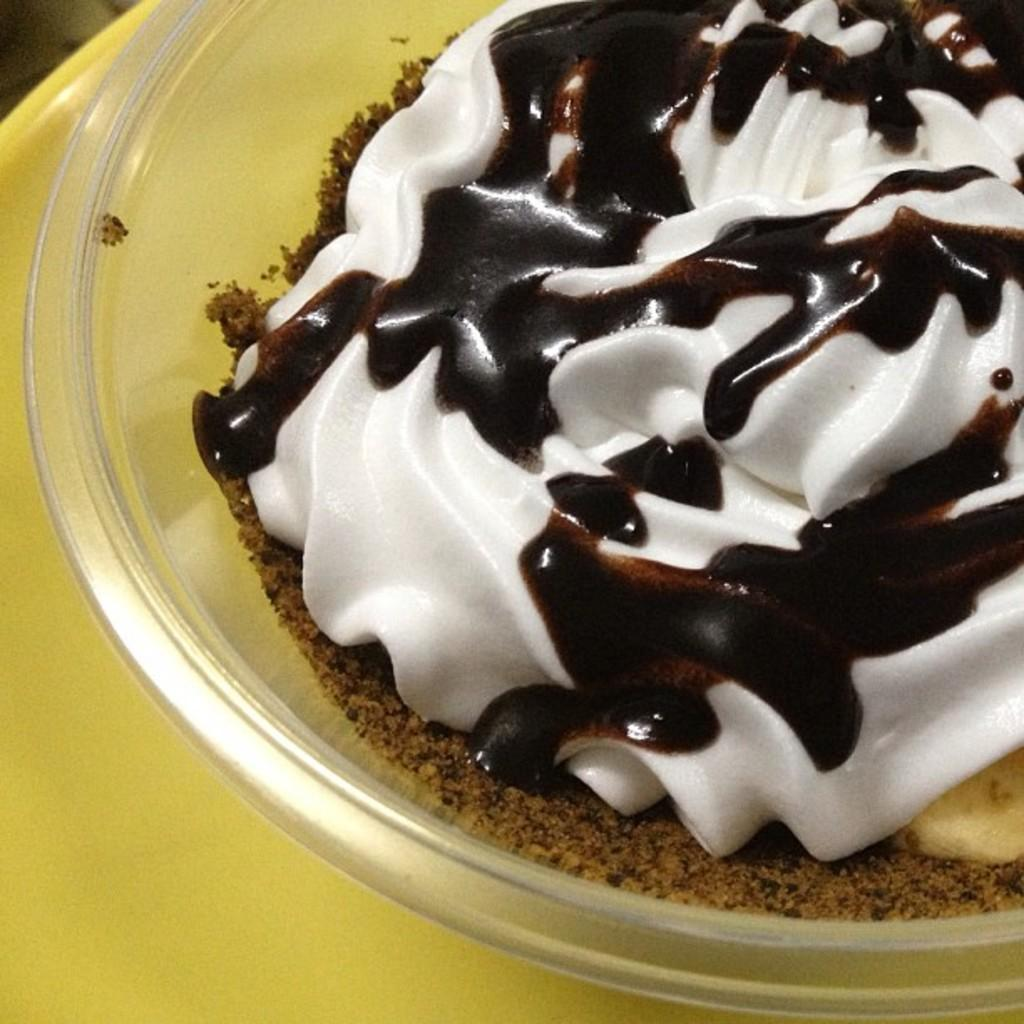What type of container is visible in the image? There is a glass bowl in the image. What is inside the glass bowl? There is an ice cream in the bowl. What is the color of the ice cream? The ice cream is white in color. What is added to the ice cream? There is chocolate syrup on the ice cream. What scientific experiment is being conducted in the image? There is no scientific experiment visible in the image; it features a glass bowl with ice cream and chocolate syrup. 